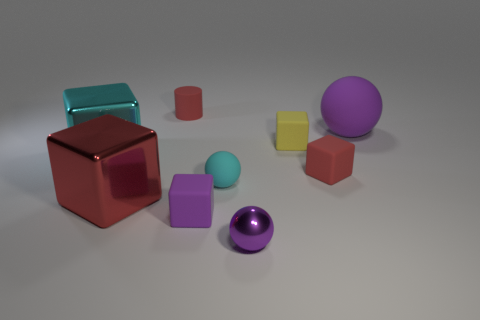Subtract all large red cubes. How many cubes are left? 4 Subtract all yellow cubes. How many cubes are left? 4 Subtract all brown cubes. Subtract all brown cylinders. How many cubes are left? 5 Subtract all cylinders. How many objects are left? 8 Add 3 small blocks. How many small blocks are left? 6 Add 6 blue rubber balls. How many blue rubber balls exist? 6 Subtract 1 yellow blocks. How many objects are left? 8 Subtract all large brown rubber cubes. Subtract all cyan cubes. How many objects are left? 8 